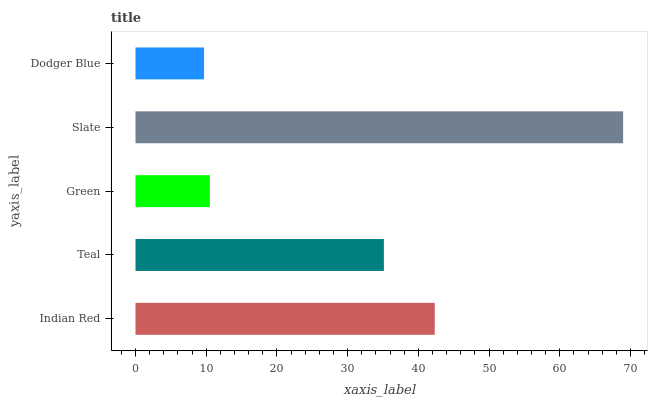Is Dodger Blue the minimum?
Answer yes or no. Yes. Is Slate the maximum?
Answer yes or no. Yes. Is Teal the minimum?
Answer yes or no. No. Is Teal the maximum?
Answer yes or no. No. Is Indian Red greater than Teal?
Answer yes or no. Yes. Is Teal less than Indian Red?
Answer yes or no. Yes. Is Teal greater than Indian Red?
Answer yes or no. No. Is Indian Red less than Teal?
Answer yes or no. No. Is Teal the high median?
Answer yes or no. Yes. Is Teal the low median?
Answer yes or no. Yes. Is Indian Red the high median?
Answer yes or no. No. Is Slate the low median?
Answer yes or no. No. 